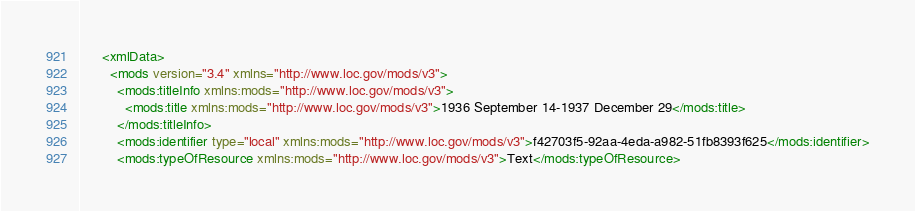<code> <loc_0><loc_0><loc_500><loc_500><_XML_>      <xmlData>
        <mods version="3.4" xmlns="http://www.loc.gov/mods/v3">
          <mods:titleInfo xmlns:mods="http://www.loc.gov/mods/v3">
            <mods:title xmlns:mods="http://www.loc.gov/mods/v3">1936 September 14-1937 December 29</mods:title>
          </mods:titleInfo>
          <mods:identifier type="local" xmlns:mods="http://www.loc.gov/mods/v3">f42703f5-92aa-4eda-a982-51fb8393f625</mods:identifier>
          <mods:typeOfResource xmlns:mods="http://www.loc.gov/mods/v3">Text</mods:typeOfResource></code> 